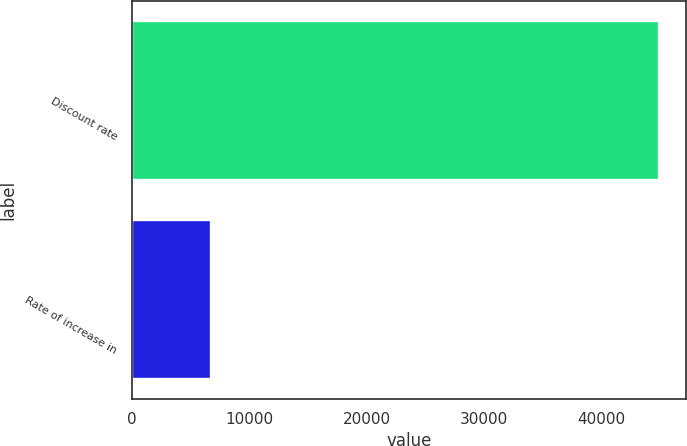Convert chart to OTSL. <chart><loc_0><loc_0><loc_500><loc_500><bar_chart><fcel>Discount rate<fcel>Rate of increase in<nl><fcel>44950<fcel>6741<nl></chart> 